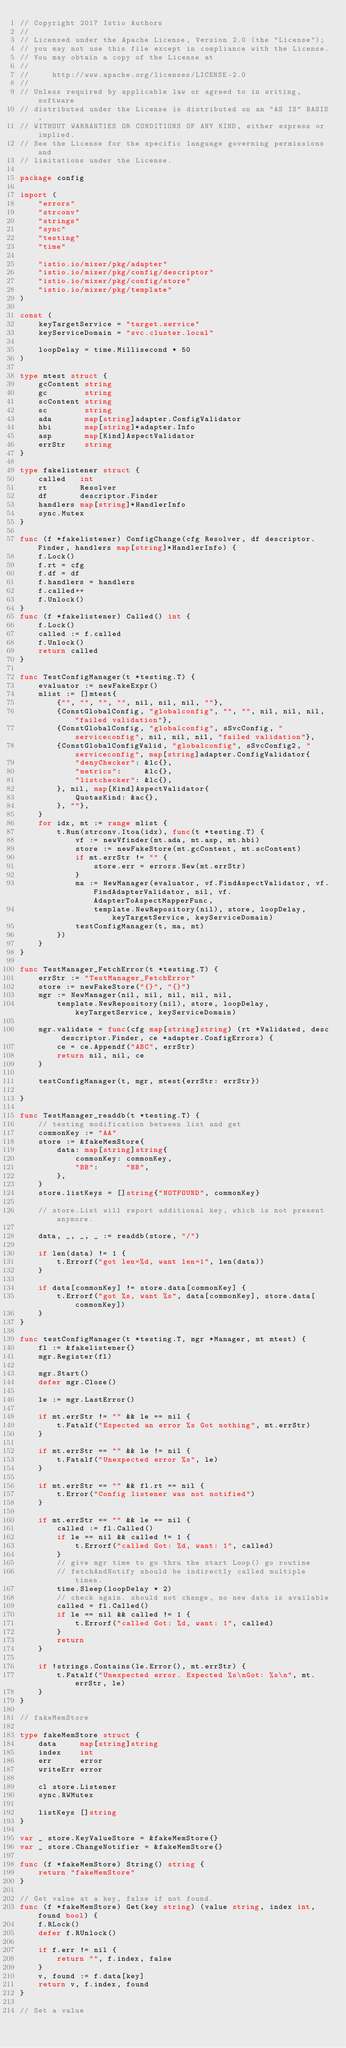<code> <loc_0><loc_0><loc_500><loc_500><_Go_>// Copyright 2017 Istio Authors
//
// Licensed under the Apache License, Version 2.0 (the "License");
// you may not use this file except in compliance with the License.
// You may obtain a copy of the License at
//
//     http://www.apache.org/licenses/LICENSE-2.0
//
// Unless required by applicable law or agreed to in writing, software
// distributed under the License is distributed on an "AS IS" BASIS,
// WITHOUT WARRANTIES OR CONDITIONS OF ANY KIND, either express or implied.
// See the License for the specific language governing permissions and
// limitations under the License.

package config

import (
	"errors"
	"strconv"
	"strings"
	"sync"
	"testing"
	"time"

	"istio.io/mixer/pkg/adapter"
	"istio.io/mixer/pkg/config/descriptor"
	"istio.io/mixer/pkg/config/store"
	"istio.io/mixer/pkg/template"
)

const (
	keyTargetService = "target.service"
	keyServiceDomain = "svc.cluster.local"

	loopDelay = time.Millisecond * 50
)

type mtest struct {
	gcContent string
	gc        string
	scContent string
	sc        string
	ada       map[string]adapter.ConfigValidator
	hbi       map[string]*adapter.Info
	asp       map[Kind]AspectValidator
	errStr    string
}

type fakelistener struct {
	called   int
	rt       Resolver
	df       descriptor.Finder
	handlers map[string]*HandlerInfo
	sync.Mutex
}

func (f *fakelistener) ConfigChange(cfg Resolver, df descriptor.Finder, handlers map[string]*HandlerInfo) {
	f.Lock()
	f.rt = cfg
	f.df = df
	f.handlers = handlers
	f.called++
	f.Unlock()
}
func (f *fakelistener) Called() int {
	f.Lock()
	called := f.called
	f.Unlock()
	return called
}

func TestConfigManager(t *testing.T) {
	evaluator := newFakeExpr()
	mlist := []mtest{
		{"", "", "", "", nil, nil, nil, ""},
		{ConstGlobalConfig, "globalconfig", "", "", nil, nil, nil, "failed validation"},
		{ConstGlobalConfig, "globalconfig", sSvcConfig, "serviceconfig", nil, nil, nil, "failed validation"},
		{ConstGlobalConfigValid, "globalconfig", sSvcConfig2, "serviceconfig", map[string]adapter.ConfigValidator{
			"denyChecker": &lc{},
			"metrics":     &lc{},
			"listchecker": &lc{},
		}, nil, map[Kind]AspectValidator{
			QuotasKind: &ac{},
		}, ""},
	}
	for idx, mt := range mlist {
		t.Run(strconv.Itoa(idx), func(t *testing.T) {
			vf := newVfinder(mt.ada, mt.asp, mt.hbi)
			store := newFakeStore(mt.gcContent, mt.scContent)
			if mt.errStr != "" {
				store.err = errors.New(mt.errStr)
			}
			ma := NewManager(evaluator, vf.FindAspectValidator, vf.FindAdapterValidator, nil, vf.AdapterToAspectMapperFunc,
				template.NewRepository(nil), store, loopDelay, keyTargetService, keyServiceDomain)
			testConfigManager(t, ma, mt)
		})
	}
}

func TestManager_FetchError(t *testing.T) {
	errStr := "TestManager_FetchError"
	store := newFakeStore("{}", "{}")
	mgr := NewManager(nil, nil, nil, nil, nil,
		template.NewRepository(nil), store, loopDelay, keyTargetService, keyServiceDomain)

	mgr.validate = func(cfg map[string]string) (rt *Validated, desc descriptor.Finder, ce *adapter.ConfigErrors) {
		ce = ce.Appendf("ABC", errStr)
		return nil, nil, ce
	}

	testConfigManager(t, mgr, mtest{errStr: errStr})

}

func TestManager_readdb(t *testing.T) {
	// testing modification between list and get
	commonKey := "AA"
	store := &fakeMemStore{
		data: map[string]string{
			commonKey: commonKey,
			"BB":      "BB",
		},
	}
	store.listKeys = []string{"NOTFOUND", commonKey}

	// store.List will report additional key, which is not present anymore.

	data, _, _, _ := readdb(store, "/")

	if len(data) != 1 {
		t.Errorf("got len=%d, want len=1", len(data))
	}

	if data[commonKey] != store.data[commonKey] {
		t.Errorf("got %s, want %s", data[commonKey], store.data[commonKey])
	}
}

func testConfigManager(t *testing.T, mgr *Manager, mt mtest) {
	fl := &fakelistener{}
	mgr.Register(fl)

	mgr.Start()
	defer mgr.Close()

	le := mgr.LastError()

	if mt.errStr != "" && le == nil {
		t.Fatalf("Expected an error %s Got nothing", mt.errStr)
	}

	if mt.errStr == "" && le != nil {
		t.Fatalf("Unexpected error %s", le)
	}

	if mt.errStr == "" && fl.rt == nil {
		t.Error("Config listener was not notified")
	}

	if mt.errStr == "" && le == nil {
		called := fl.Called()
		if le == nil && called != 1 {
			t.Errorf("called Got: %d, want: 1", called)
		}
		// give mgr time to go thru the start Loop() go routine
		// fetchAndNotify should be indirectly called multiple times.
		time.Sleep(loopDelay * 2)
		// check again. should not change, no new data is available
		called = fl.Called()
		if le == nil && called != 1 {
			t.Errorf("called Got: %d, want: 1", called)
		}
		return
	}

	if !strings.Contains(le.Error(), mt.errStr) {
		t.Fatalf("Unexpected error. Expected %s\nGot: %s\n", mt.errStr, le)
	}
}

// fakeMemStore

type fakeMemStore struct {
	data     map[string]string
	index    int
	err      error
	writeErr error

	cl store.Listener
	sync.RWMutex

	listKeys []string
}

var _ store.KeyValueStore = &fakeMemStore{}
var _ store.ChangeNotifier = &fakeMemStore{}

func (f *fakeMemStore) String() string {
	return "fakeMemStore"
}

// Get value at a key, false if not found.
func (f *fakeMemStore) Get(key string) (value string, index int, found bool) {
	f.RLock()
	defer f.RUnlock()

	if f.err != nil {
		return "", f.index, false
	}
	v, found := f.data[key]
	return v, f.index, found
}

// Set a value</code> 